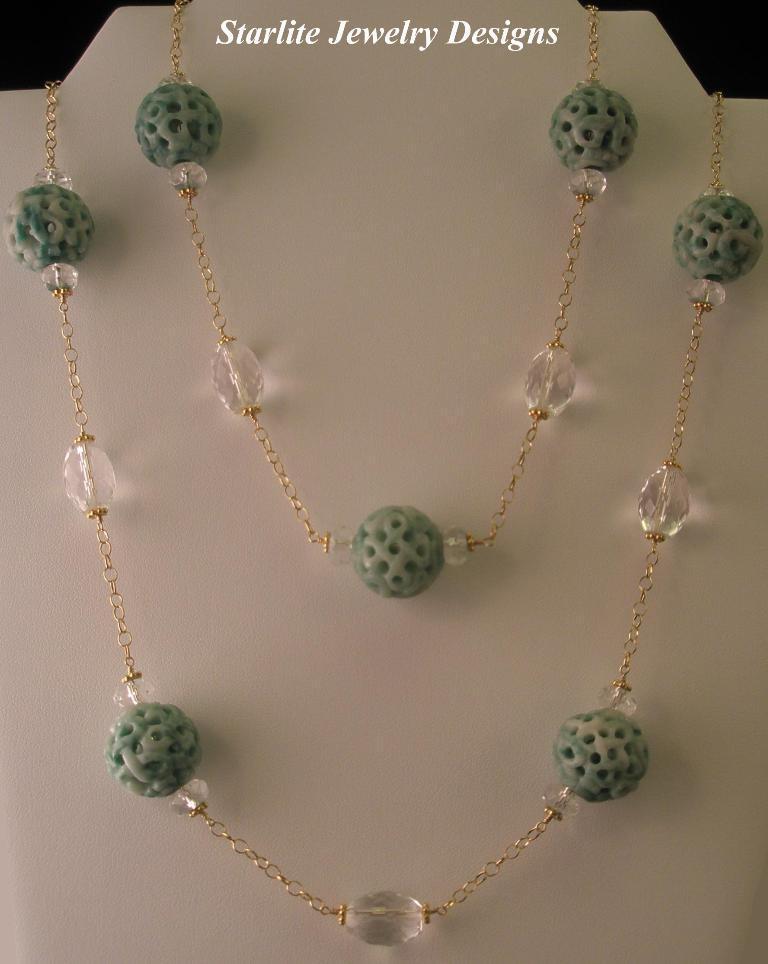Could you give a brief overview of what you see in this image? In this picture there is a green and white color beats in the necklace which is placed on the white color neck holder. Above on the top we can see a small quote on which "Starlite jewelry design'' is written. 